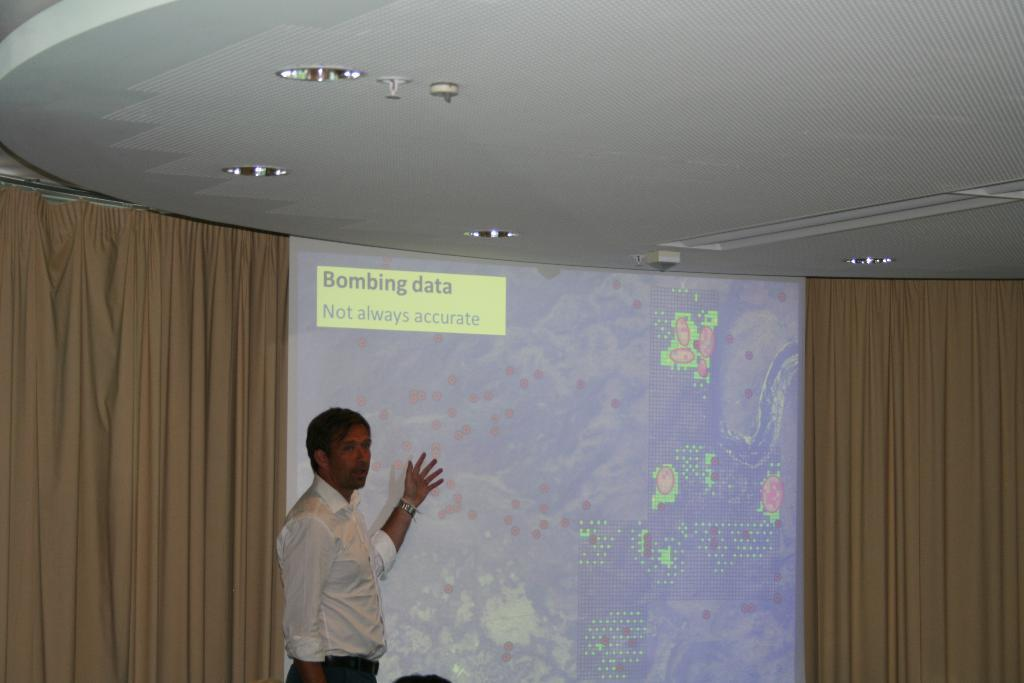What is the main subject of the image? There is a man standing in the image. What is the man standing in front of? The man is standing before a projector display. What type of lighting is present in the image? There are electric lights visible in the image. What type of window treatment is present in the image? There are curtains in the image. What condition is the notebook in during the presentation in the image? There is no notebook present in the image, so it is not possible to determine its condition. 